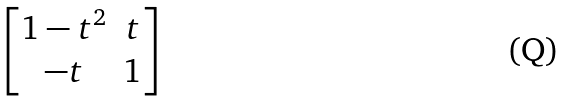<formula> <loc_0><loc_0><loc_500><loc_500>\begin{bmatrix} 1 - t ^ { 2 } & t \\ - t & 1 \end{bmatrix}</formula> 